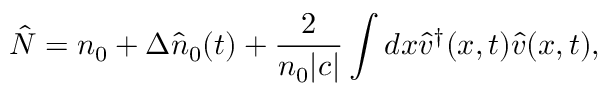<formula> <loc_0><loc_0><loc_500><loc_500>\hat { N } = n _ { 0 } + \Delta \hat { n } _ { 0 } ( t ) + \frac { 2 } { n _ { 0 } | c | } \int d x \hat { v } ^ { \dagger } ( x , t ) \hat { v } ( x , t ) ,</formula> 